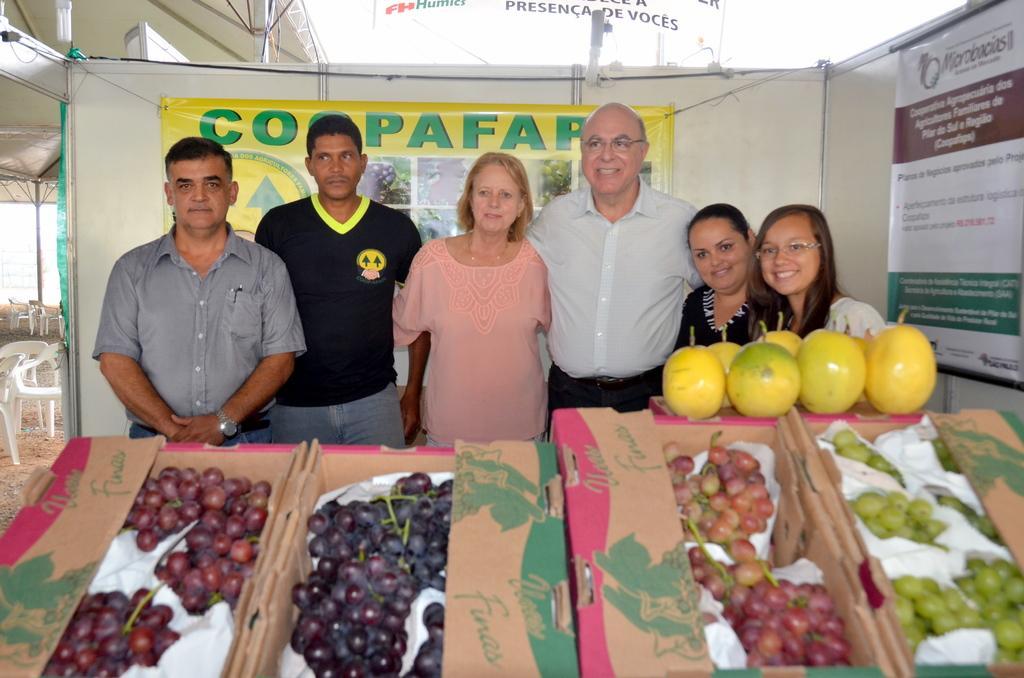In one or two sentences, can you explain what this image depicts? In this image few persons are standing behind the boxes having few grapes in it. There are different colours of grapes in boxes. Right side there are fruits on the box. Behind it there are two women. A person wearing a white shirt is having spectacles, beside him there is a woman standing. Behind them there is a banner attached to the wall. Left side there are few chairs on the land which are under the tent. 